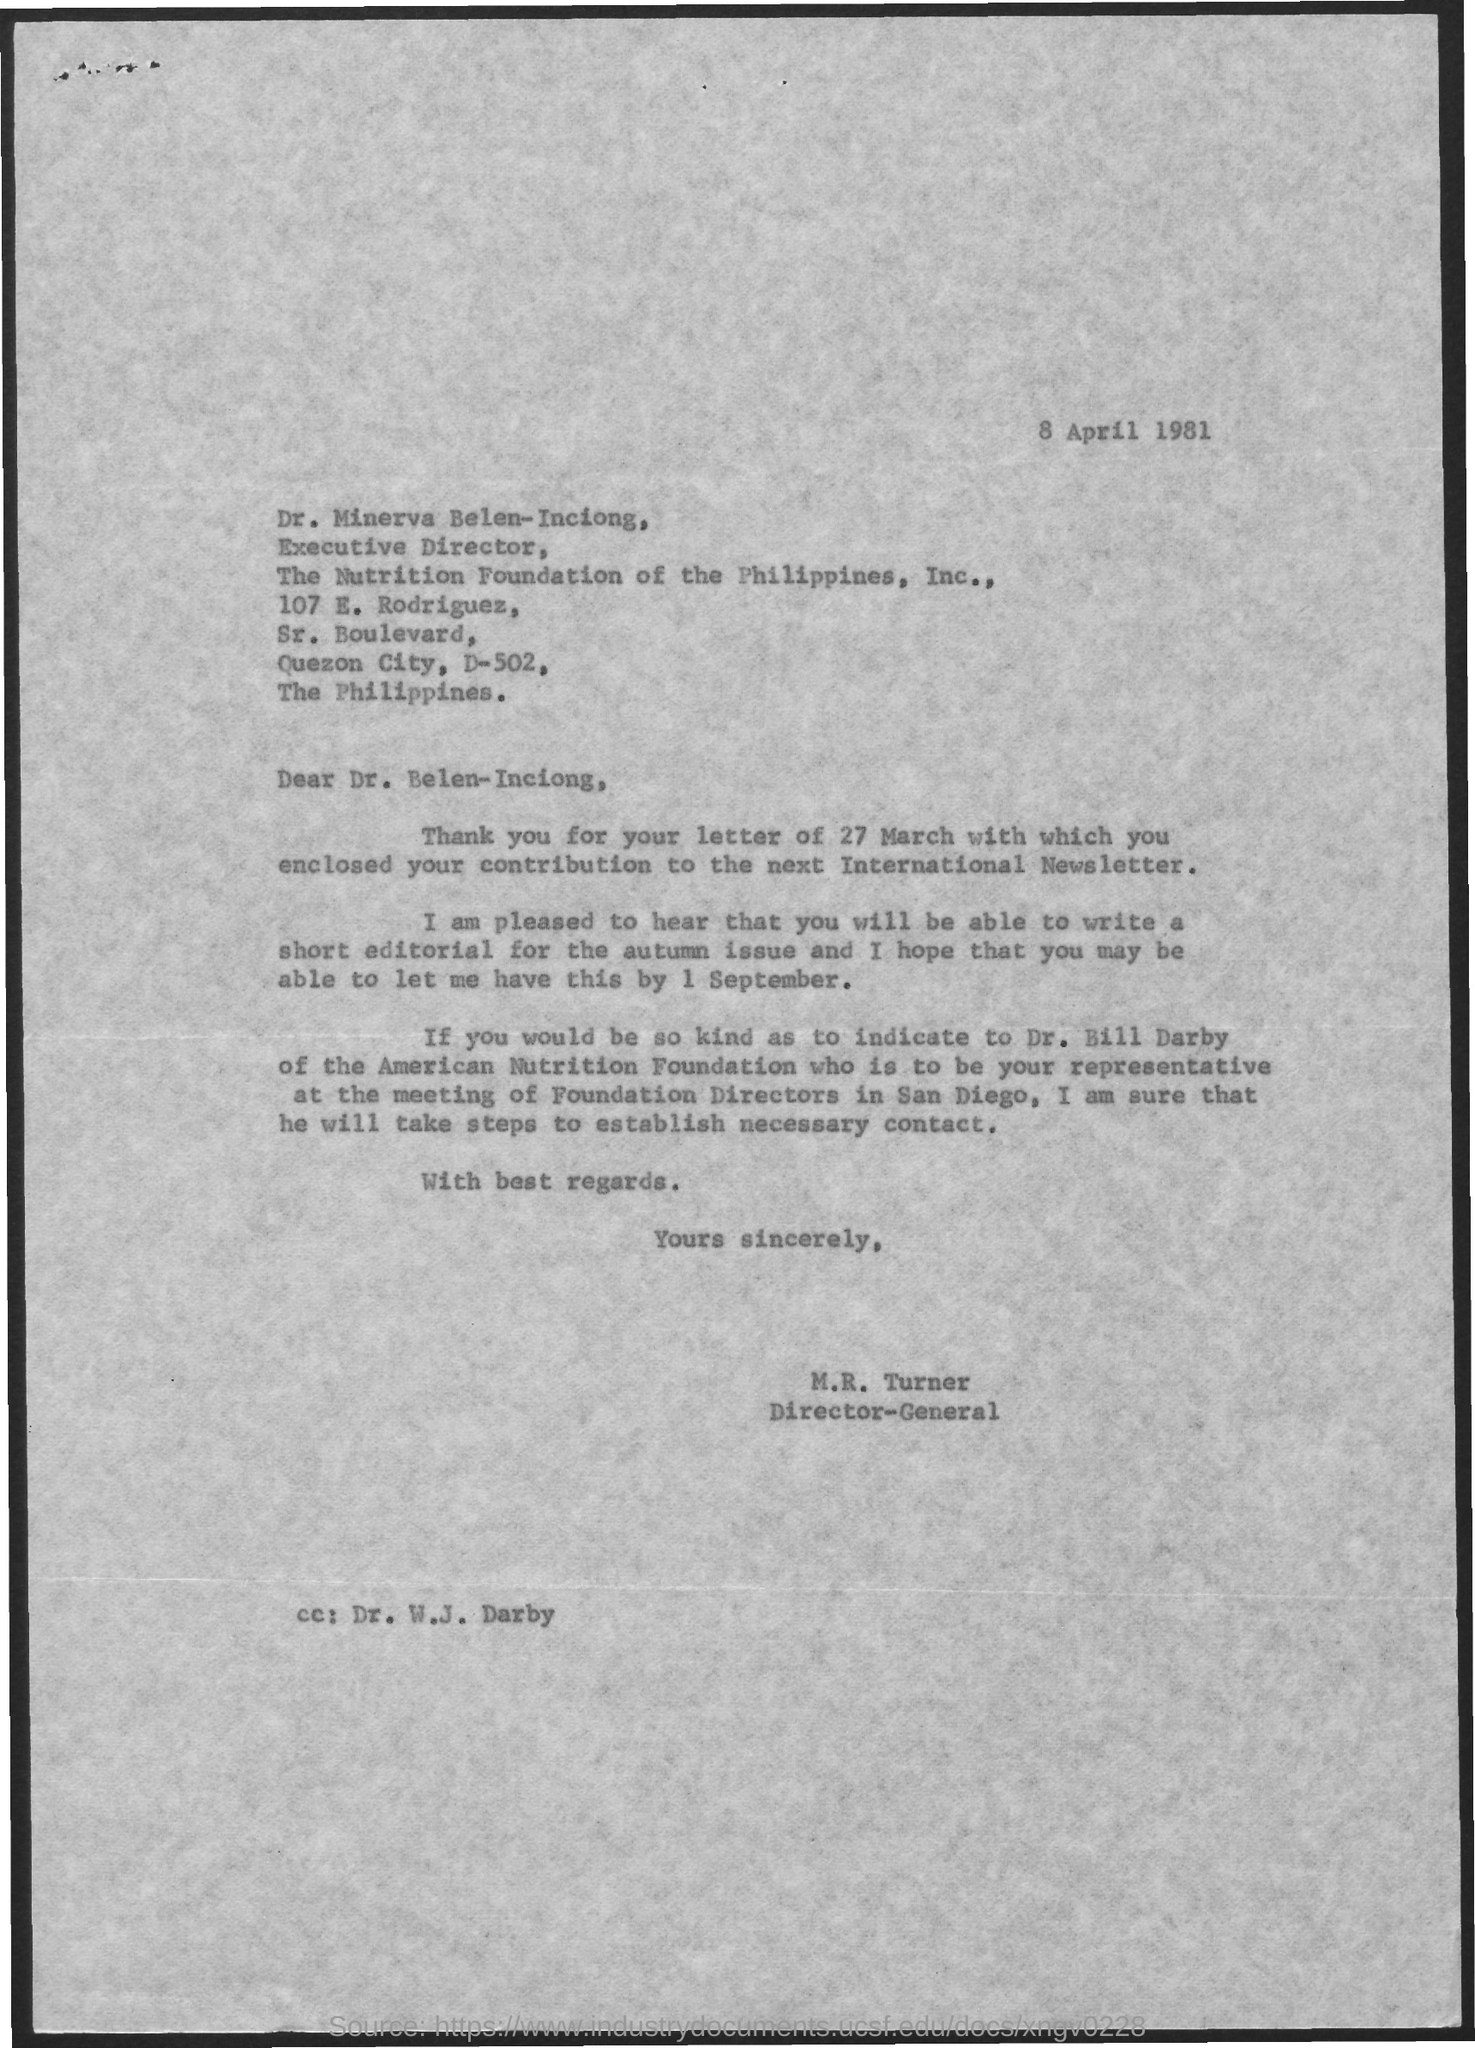What is the designation of dr. minerva belen-inciong ?
Offer a terse response. Executive Director. 